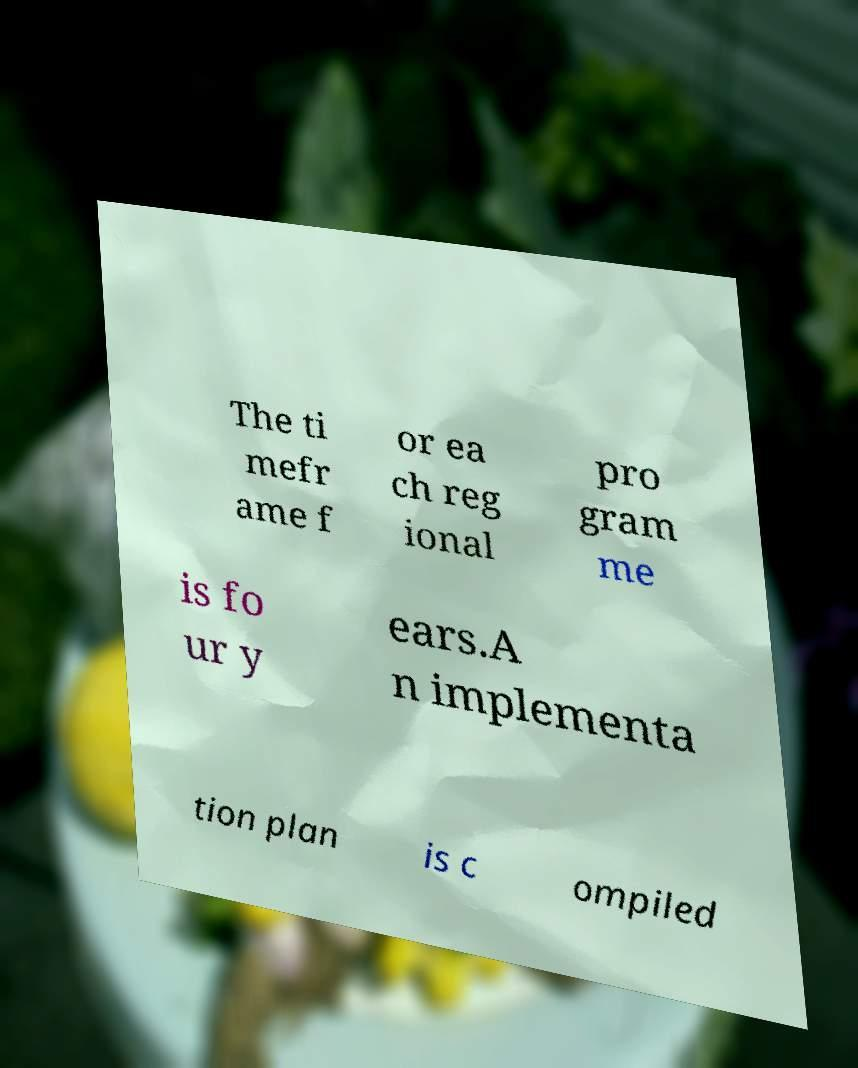Please read and relay the text visible in this image. What does it say? The ti mefr ame f or ea ch reg ional pro gram me is fo ur y ears.A n implementa tion plan is c ompiled 